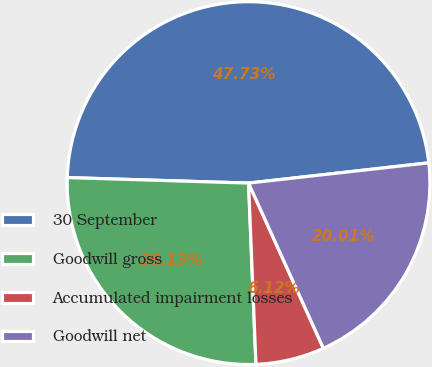Convert chart to OTSL. <chart><loc_0><loc_0><loc_500><loc_500><pie_chart><fcel>30 September<fcel>Goodwill gross<fcel>Accumulated impairment losses<fcel>Goodwill net<nl><fcel>47.73%<fcel>26.13%<fcel>6.12%<fcel>20.01%<nl></chart> 